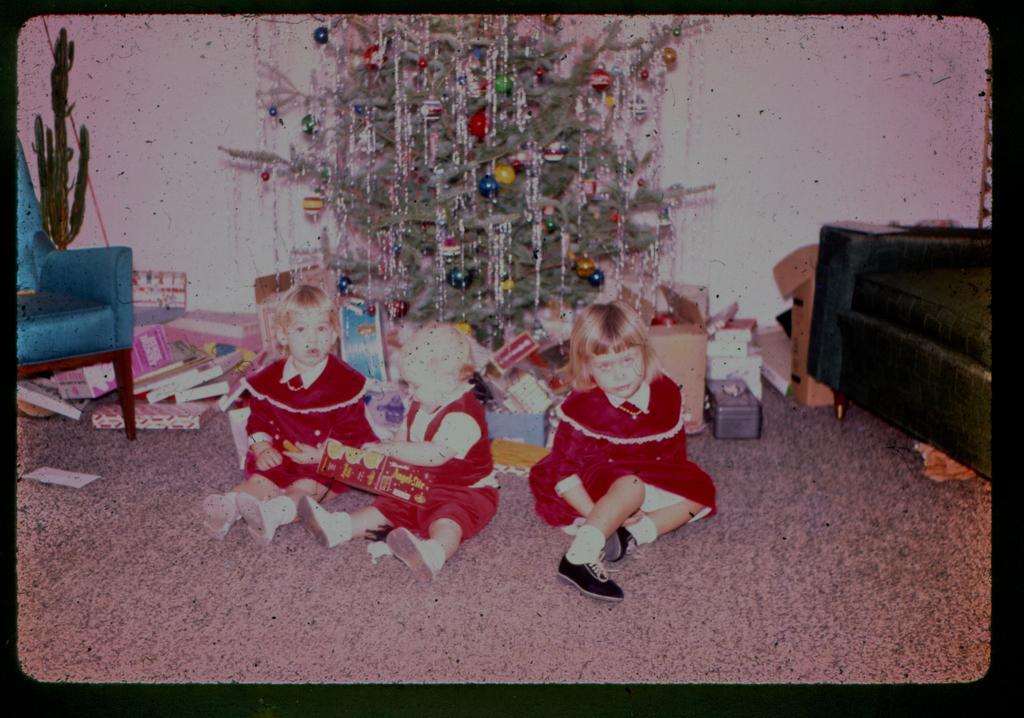Please provide a concise description of this image. It is a picture there are three kids sitting on the floor they are wearing red color costume, in the background is decorated tree , on the either side of the tree to the right right there is a sofa and to the left side there is a chair in the background and pink color wall. 